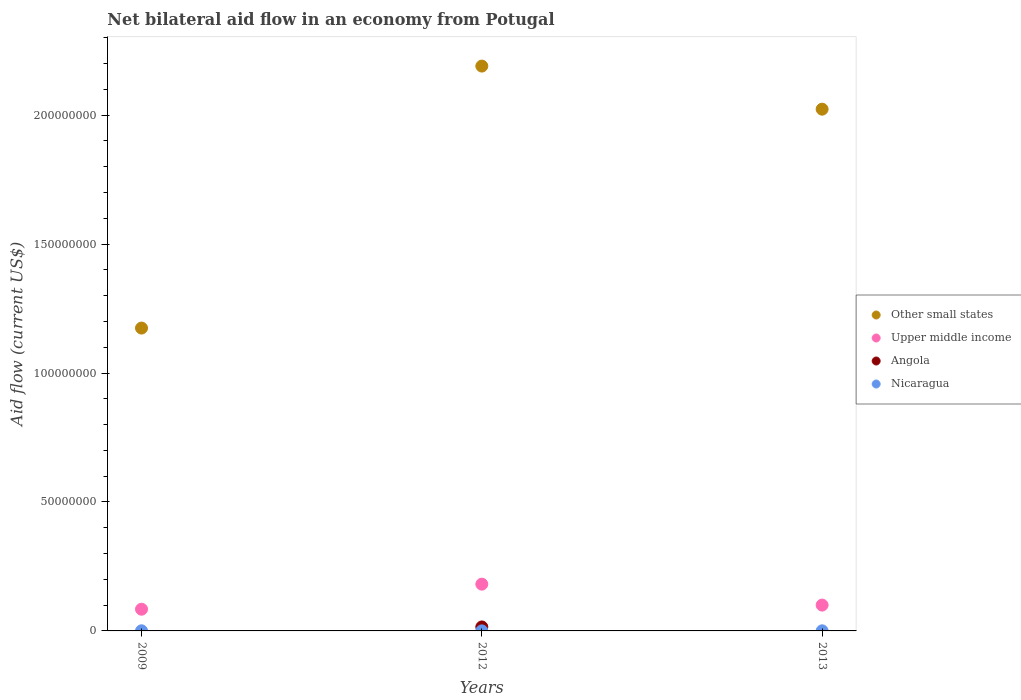How many different coloured dotlines are there?
Offer a terse response. 4. Is the number of dotlines equal to the number of legend labels?
Offer a very short reply. No. What is the net bilateral aid flow in Upper middle income in 2013?
Provide a short and direct response. 1.00e+07. Across all years, what is the maximum net bilateral aid flow in Other small states?
Your answer should be very brief. 2.19e+08. Across all years, what is the minimum net bilateral aid flow in Upper middle income?
Give a very brief answer. 8.42e+06. In which year was the net bilateral aid flow in Nicaragua maximum?
Offer a terse response. 2009. What is the total net bilateral aid flow in Upper middle income in the graph?
Offer a very short reply. 3.66e+07. What is the difference between the net bilateral aid flow in Upper middle income in 2012 and that in 2013?
Provide a short and direct response. 8.12e+06. What is the difference between the net bilateral aid flow in Angola in 2012 and the net bilateral aid flow in Nicaragua in 2009?
Make the answer very short. 1.49e+06. What is the average net bilateral aid flow in Upper middle income per year?
Ensure brevity in your answer.  1.22e+07. In the year 2013, what is the difference between the net bilateral aid flow in Other small states and net bilateral aid flow in Nicaragua?
Give a very brief answer. 2.02e+08. What is the ratio of the net bilateral aid flow in Nicaragua in 2012 to that in 2013?
Your answer should be compact. 0.5. What is the difference between the highest and the second highest net bilateral aid flow in Upper middle income?
Your response must be concise. 8.12e+06. What is the difference between the highest and the lowest net bilateral aid flow in Other small states?
Offer a very short reply. 1.02e+08. In how many years, is the net bilateral aid flow in Angola greater than the average net bilateral aid flow in Angola taken over all years?
Give a very brief answer. 1. Is it the case that in every year, the sum of the net bilateral aid flow in Angola and net bilateral aid flow in Nicaragua  is greater than the net bilateral aid flow in Upper middle income?
Ensure brevity in your answer.  No. Does the net bilateral aid flow in Nicaragua monotonically increase over the years?
Keep it short and to the point. No. What is the difference between two consecutive major ticks on the Y-axis?
Provide a succinct answer. 5.00e+07. Are the values on the major ticks of Y-axis written in scientific E-notation?
Keep it short and to the point. No. Where does the legend appear in the graph?
Provide a succinct answer. Center right. How are the legend labels stacked?
Your response must be concise. Vertical. What is the title of the graph?
Provide a succinct answer. Net bilateral aid flow in an economy from Potugal. Does "Other small states" appear as one of the legend labels in the graph?
Your answer should be very brief. Yes. What is the Aid flow (current US$) of Other small states in 2009?
Keep it short and to the point. 1.17e+08. What is the Aid flow (current US$) in Upper middle income in 2009?
Your answer should be compact. 8.42e+06. What is the Aid flow (current US$) in Other small states in 2012?
Make the answer very short. 2.19e+08. What is the Aid flow (current US$) in Upper middle income in 2012?
Make the answer very short. 1.81e+07. What is the Aid flow (current US$) in Angola in 2012?
Provide a succinct answer. 1.54e+06. What is the Aid flow (current US$) of Other small states in 2013?
Keep it short and to the point. 2.02e+08. What is the Aid flow (current US$) of Upper middle income in 2013?
Your answer should be very brief. 1.00e+07. What is the Aid flow (current US$) in Nicaragua in 2013?
Keep it short and to the point. 4.00e+04. Across all years, what is the maximum Aid flow (current US$) of Other small states?
Your answer should be very brief. 2.19e+08. Across all years, what is the maximum Aid flow (current US$) in Upper middle income?
Provide a short and direct response. 1.81e+07. Across all years, what is the maximum Aid flow (current US$) of Angola?
Provide a succinct answer. 1.54e+06. Across all years, what is the minimum Aid flow (current US$) in Other small states?
Provide a short and direct response. 1.17e+08. Across all years, what is the minimum Aid flow (current US$) of Upper middle income?
Keep it short and to the point. 8.42e+06. Across all years, what is the minimum Aid flow (current US$) in Angola?
Offer a terse response. 0. What is the total Aid flow (current US$) in Other small states in the graph?
Your answer should be compact. 5.39e+08. What is the total Aid flow (current US$) of Upper middle income in the graph?
Provide a succinct answer. 3.66e+07. What is the total Aid flow (current US$) of Angola in the graph?
Make the answer very short. 1.54e+06. What is the difference between the Aid flow (current US$) in Other small states in 2009 and that in 2012?
Provide a succinct answer. -1.02e+08. What is the difference between the Aid flow (current US$) in Upper middle income in 2009 and that in 2012?
Provide a short and direct response. -9.72e+06. What is the difference between the Aid flow (current US$) of Other small states in 2009 and that in 2013?
Your answer should be very brief. -8.49e+07. What is the difference between the Aid flow (current US$) in Upper middle income in 2009 and that in 2013?
Make the answer very short. -1.60e+06. What is the difference between the Aid flow (current US$) in Other small states in 2012 and that in 2013?
Keep it short and to the point. 1.67e+07. What is the difference between the Aid flow (current US$) in Upper middle income in 2012 and that in 2013?
Ensure brevity in your answer.  8.12e+06. What is the difference between the Aid flow (current US$) in Nicaragua in 2012 and that in 2013?
Keep it short and to the point. -2.00e+04. What is the difference between the Aid flow (current US$) of Other small states in 2009 and the Aid flow (current US$) of Upper middle income in 2012?
Your response must be concise. 9.93e+07. What is the difference between the Aid flow (current US$) of Other small states in 2009 and the Aid flow (current US$) of Angola in 2012?
Ensure brevity in your answer.  1.16e+08. What is the difference between the Aid flow (current US$) in Other small states in 2009 and the Aid flow (current US$) in Nicaragua in 2012?
Give a very brief answer. 1.17e+08. What is the difference between the Aid flow (current US$) of Upper middle income in 2009 and the Aid flow (current US$) of Angola in 2012?
Offer a terse response. 6.88e+06. What is the difference between the Aid flow (current US$) of Upper middle income in 2009 and the Aid flow (current US$) of Nicaragua in 2012?
Your answer should be compact. 8.40e+06. What is the difference between the Aid flow (current US$) in Other small states in 2009 and the Aid flow (current US$) in Upper middle income in 2013?
Your answer should be compact. 1.07e+08. What is the difference between the Aid flow (current US$) of Other small states in 2009 and the Aid flow (current US$) of Nicaragua in 2013?
Your answer should be compact. 1.17e+08. What is the difference between the Aid flow (current US$) of Upper middle income in 2009 and the Aid flow (current US$) of Nicaragua in 2013?
Offer a very short reply. 8.38e+06. What is the difference between the Aid flow (current US$) of Other small states in 2012 and the Aid flow (current US$) of Upper middle income in 2013?
Keep it short and to the point. 2.09e+08. What is the difference between the Aid flow (current US$) of Other small states in 2012 and the Aid flow (current US$) of Nicaragua in 2013?
Your response must be concise. 2.19e+08. What is the difference between the Aid flow (current US$) in Upper middle income in 2012 and the Aid flow (current US$) in Nicaragua in 2013?
Your answer should be compact. 1.81e+07. What is the difference between the Aid flow (current US$) in Angola in 2012 and the Aid flow (current US$) in Nicaragua in 2013?
Keep it short and to the point. 1.50e+06. What is the average Aid flow (current US$) in Other small states per year?
Provide a succinct answer. 1.80e+08. What is the average Aid flow (current US$) in Upper middle income per year?
Your answer should be very brief. 1.22e+07. What is the average Aid flow (current US$) of Angola per year?
Offer a very short reply. 5.13e+05. What is the average Aid flow (current US$) in Nicaragua per year?
Keep it short and to the point. 3.67e+04. In the year 2009, what is the difference between the Aid flow (current US$) in Other small states and Aid flow (current US$) in Upper middle income?
Offer a terse response. 1.09e+08. In the year 2009, what is the difference between the Aid flow (current US$) of Other small states and Aid flow (current US$) of Nicaragua?
Your answer should be compact. 1.17e+08. In the year 2009, what is the difference between the Aid flow (current US$) of Upper middle income and Aid flow (current US$) of Nicaragua?
Provide a succinct answer. 8.37e+06. In the year 2012, what is the difference between the Aid flow (current US$) in Other small states and Aid flow (current US$) in Upper middle income?
Offer a terse response. 2.01e+08. In the year 2012, what is the difference between the Aid flow (current US$) in Other small states and Aid flow (current US$) in Angola?
Offer a very short reply. 2.18e+08. In the year 2012, what is the difference between the Aid flow (current US$) of Other small states and Aid flow (current US$) of Nicaragua?
Offer a very short reply. 2.19e+08. In the year 2012, what is the difference between the Aid flow (current US$) of Upper middle income and Aid flow (current US$) of Angola?
Provide a succinct answer. 1.66e+07. In the year 2012, what is the difference between the Aid flow (current US$) of Upper middle income and Aid flow (current US$) of Nicaragua?
Make the answer very short. 1.81e+07. In the year 2012, what is the difference between the Aid flow (current US$) of Angola and Aid flow (current US$) of Nicaragua?
Your answer should be very brief. 1.52e+06. In the year 2013, what is the difference between the Aid flow (current US$) of Other small states and Aid flow (current US$) of Upper middle income?
Provide a succinct answer. 1.92e+08. In the year 2013, what is the difference between the Aid flow (current US$) in Other small states and Aid flow (current US$) in Nicaragua?
Your answer should be very brief. 2.02e+08. In the year 2013, what is the difference between the Aid flow (current US$) in Upper middle income and Aid flow (current US$) in Nicaragua?
Keep it short and to the point. 9.98e+06. What is the ratio of the Aid flow (current US$) in Other small states in 2009 to that in 2012?
Keep it short and to the point. 0.54. What is the ratio of the Aid flow (current US$) in Upper middle income in 2009 to that in 2012?
Your response must be concise. 0.46. What is the ratio of the Aid flow (current US$) of Nicaragua in 2009 to that in 2012?
Give a very brief answer. 2.5. What is the ratio of the Aid flow (current US$) in Other small states in 2009 to that in 2013?
Your answer should be very brief. 0.58. What is the ratio of the Aid flow (current US$) of Upper middle income in 2009 to that in 2013?
Give a very brief answer. 0.84. What is the ratio of the Aid flow (current US$) in Nicaragua in 2009 to that in 2013?
Offer a very short reply. 1.25. What is the ratio of the Aid flow (current US$) of Other small states in 2012 to that in 2013?
Your answer should be very brief. 1.08. What is the ratio of the Aid flow (current US$) of Upper middle income in 2012 to that in 2013?
Offer a terse response. 1.81. What is the difference between the highest and the second highest Aid flow (current US$) in Other small states?
Offer a very short reply. 1.67e+07. What is the difference between the highest and the second highest Aid flow (current US$) of Upper middle income?
Provide a succinct answer. 8.12e+06. What is the difference between the highest and the second highest Aid flow (current US$) in Nicaragua?
Your response must be concise. 10000. What is the difference between the highest and the lowest Aid flow (current US$) in Other small states?
Offer a very short reply. 1.02e+08. What is the difference between the highest and the lowest Aid flow (current US$) in Upper middle income?
Provide a succinct answer. 9.72e+06. What is the difference between the highest and the lowest Aid flow (current US$) in Angola?
Make the answer very short. 1.54e+06. What is the difference between the highest and the lowest Aid flow (current US$) in Nicaragua?
Make the answer very short. 3.00e+04. 